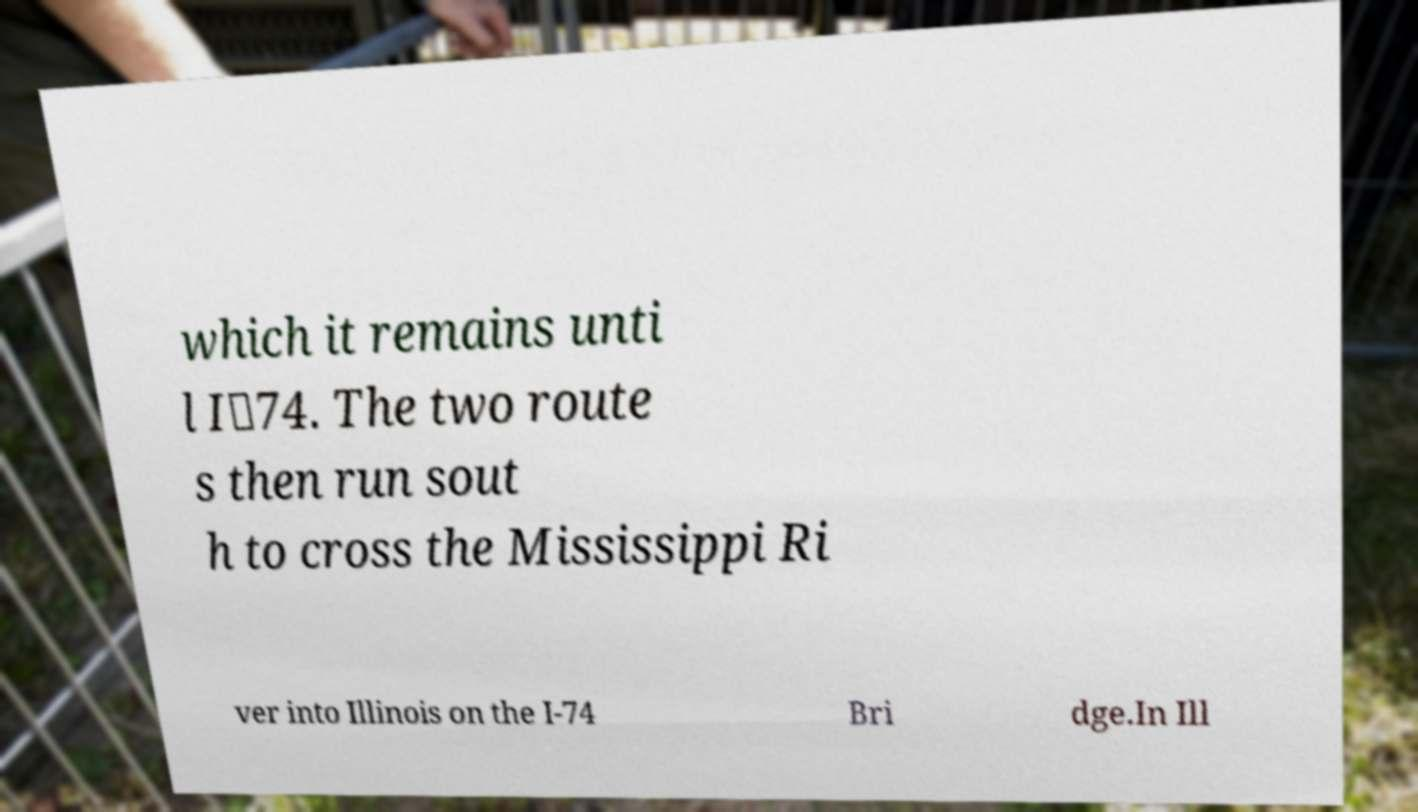Could you extract and type out the text from this image? which it remains unti l I‑74. The two route s then run sout h to cross the Mississippi Ri ver into Illinois on the I-74 Bri dge.In Ill 